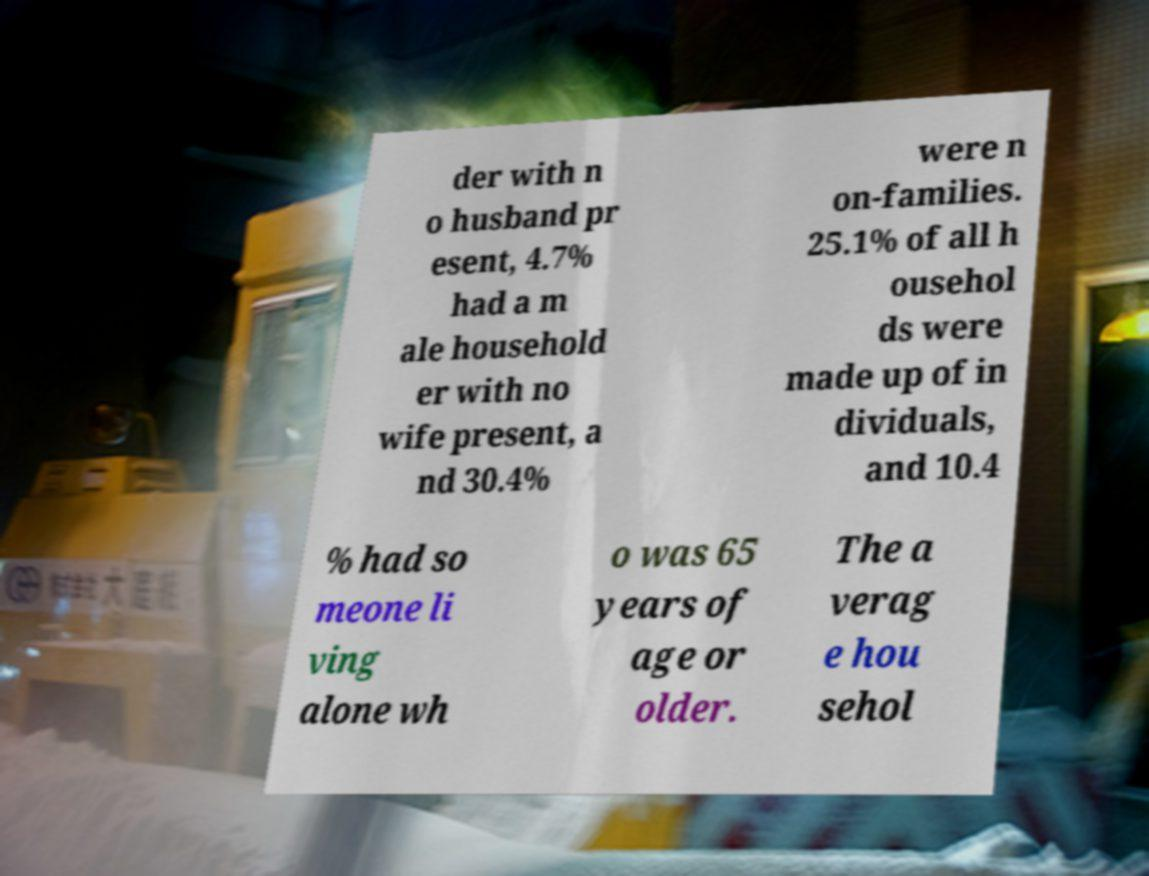What messages or text are displayed in this image? I need them in a readable, typed format. der with n o husband pr esent, 4.7% had a m ale household er with no wife present, a nd 30.4% were n on-families. 25.1% of all h ousehol ds were made up of in dividuals, and 10.4 % had so meone li ving alone wh o was 65 years of age or older. The a verag e hou sehol 